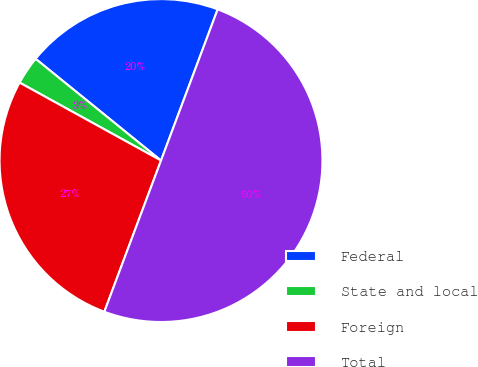Convert chart to OTSL. <chart><loc_0><loc_0><loc_500><loc_500><pie_chart><fcel>Federal<fcel>State and local<fcel>Foreign<fcel>Total<nl><fcel>19.86%<fcel>2.83%<fcel>27.31%<fcel>50.0%<nl></chart> 